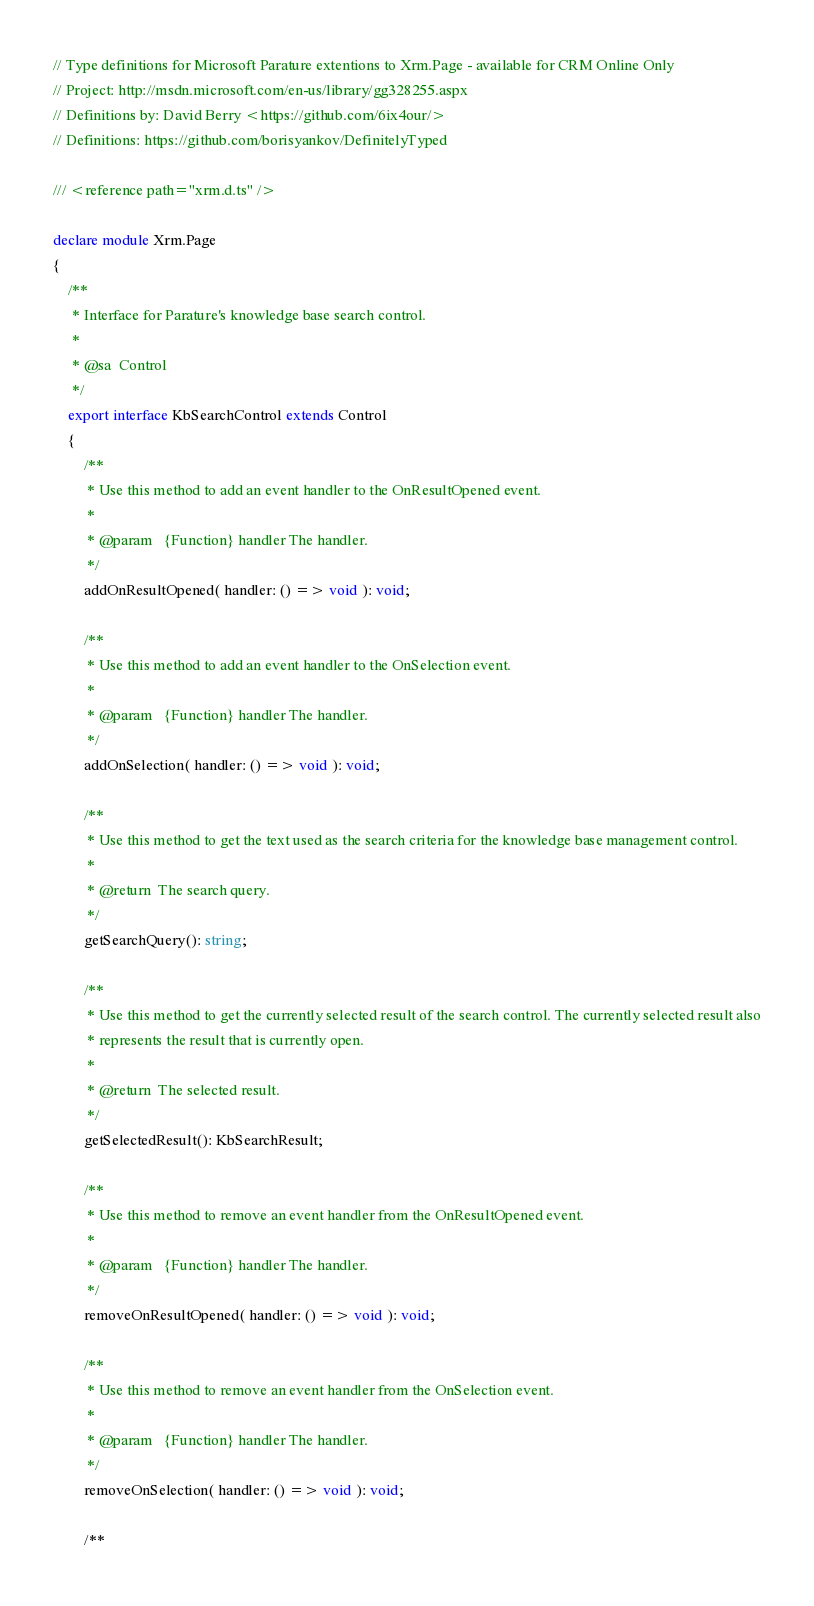<code> <loc_0><loc_0><loc_500><loc_500><_TypeScript_>// Type definitions for Microsoft Parature extentions to Xrm.Page - available for CRM Online Only
// Project: http://msdn.microsoft.com/en-us/library/gg328255.aspx
// Definitions by: David Berry <https://github.com/6ix4our/>
// Definitions: https://github.com/borisyankov/DefinitelyTyped

/// <reference path="xrm.d.ts" />

declare module Xrm.Page
{
    /**
     * Interface for Parature's knowledge base search control.
     *
     * @sa  Control
     */
    export interface KbSearchControl extends Control
    {
        /**
         * Use this method to add an event handler to the OnResultOpened event.
         *
         * @param   {Function} handler The handler.
         */
        addOnResultOpened( handler: () => void ): void;

        /**
         * Use this method to add an event handler to the OnSelection event.
         *
         * @param   {Function} handler The handler.
         */
        addOnSelection( handler: () => void ): void;

        /**
         * Use this method to get the text used as the search criteria for the knowledge base management control.
         *
         * @return  The search query.
         */
        getSearchQuery(): string;

        /**
         * Use this method to get the currently selected result of the search control. The currently selected result also
         * represents the result that is currently open.
         *
         * @return  The selected result.
         */
        getSelectedResult(): KbSearchResult;

        /**
         * Use this method to remove an event handler from the OnResultOpened event.
         *
         * @param   {Function} handler The handler.
         */
        removeOnResultOpened( handler: () => void ): void;

        /**
         * Use this method to remove an event handler from the OnSelection event.
         *
         * @param   {Function} handler The handler.
         */
        removeOnSelection( handler: () => void ): void;

        /**</code> 